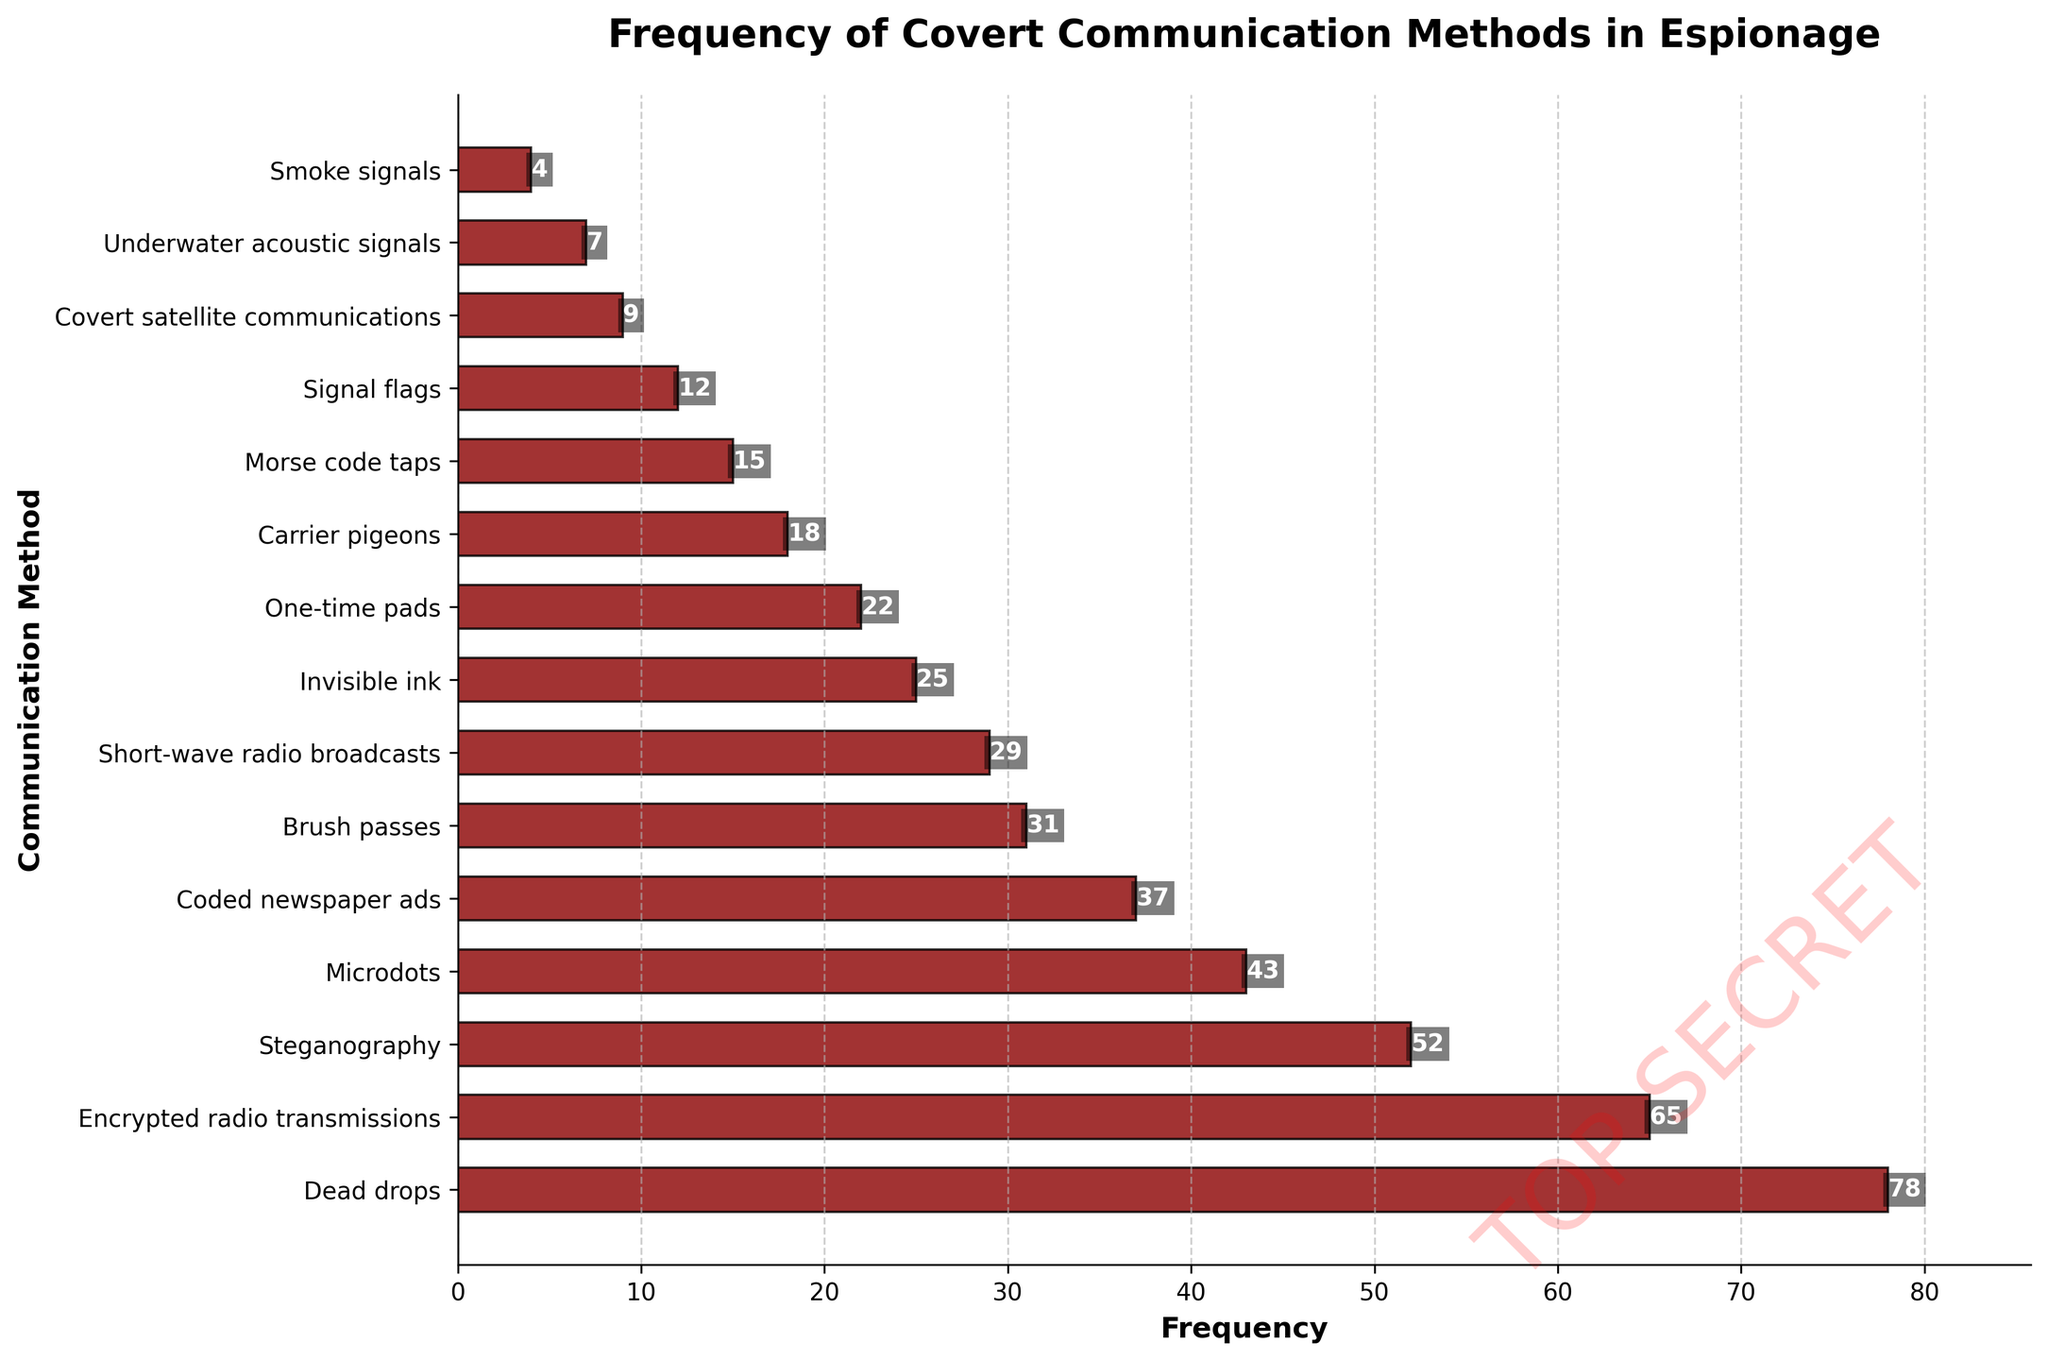How many more times were "Dead drops" used compared to "Invisible ink"? Identify the frequencies of "Dead drops" and "Invisible ink" from the bars. "Dead drops" is 78, and "Invisible ink" is 25. Subtract the frequency of "Invisible ink" from "Dead drops" (78 - 25 = 53).
Answer: 53 Which method has the lowest frequency and what is its value? Locate the shortest bar in the chart. The shortest bar is "Smoke signals" with a value of 4.
Answer: Smoke signals, 4 What are the top three most frequently used methods? Identify the methods with the three longest bars. The top three are "Dead drops" (78), "Encrypted radio transmissions" (65), and "Steganography" (52).
Answer: Dead drops, Encrypted radio transmissions, Steganography What is the total frequency of the methods used less than or equal to 20 times? Locate bars with frequencies less than or equal to 20: "Carrier pigeons" (18), "Morse code taps" (15), "Signal flags" (12), "Covert satellite communications" (9), "Underwater acoustic signals" (7), "Smoke signals" (4). Sum the frequencies: 18 + 15 + 12 + 9 + 7 + 4 = 65.
Answer: 65 How many methods have a frequency greater than 30? Count the number of bars with values greater than 30: "Dead drops" (78), "Encrypted radio transmissions" (65), "Steganography" (52), "Microdots" (43), "Coded newspaper ads" (37), "Brush passes" (31). There are six.
Answer: 6 